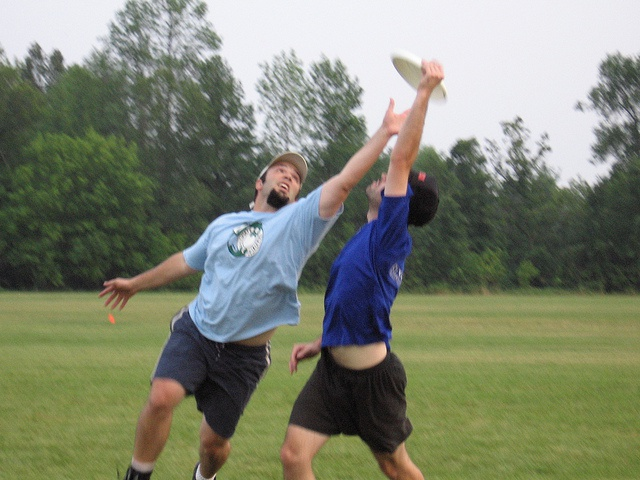Describe the objects in this image and their specific colors. I can see people in white, black, darkgray, and gray tones, people in white, black, navy, tan, and gray tones, and frisbee in white, tan, and gray tones in this image. 